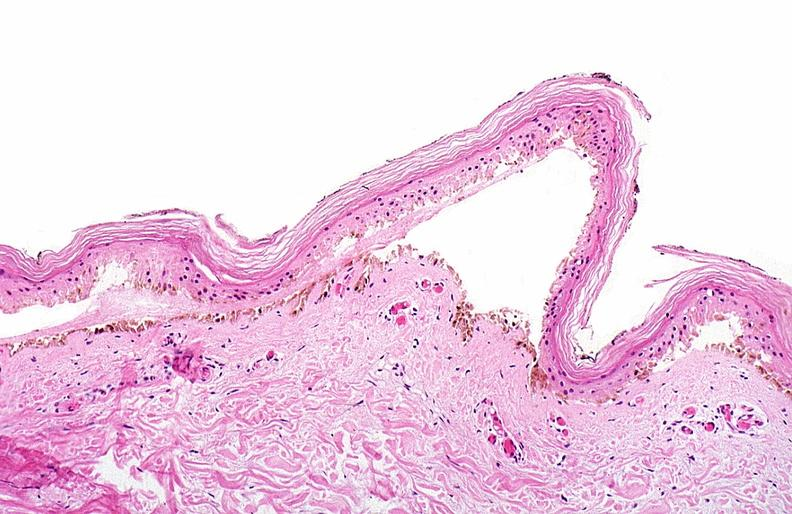where is this?
Answer the question using a single word or phrase. Skin 